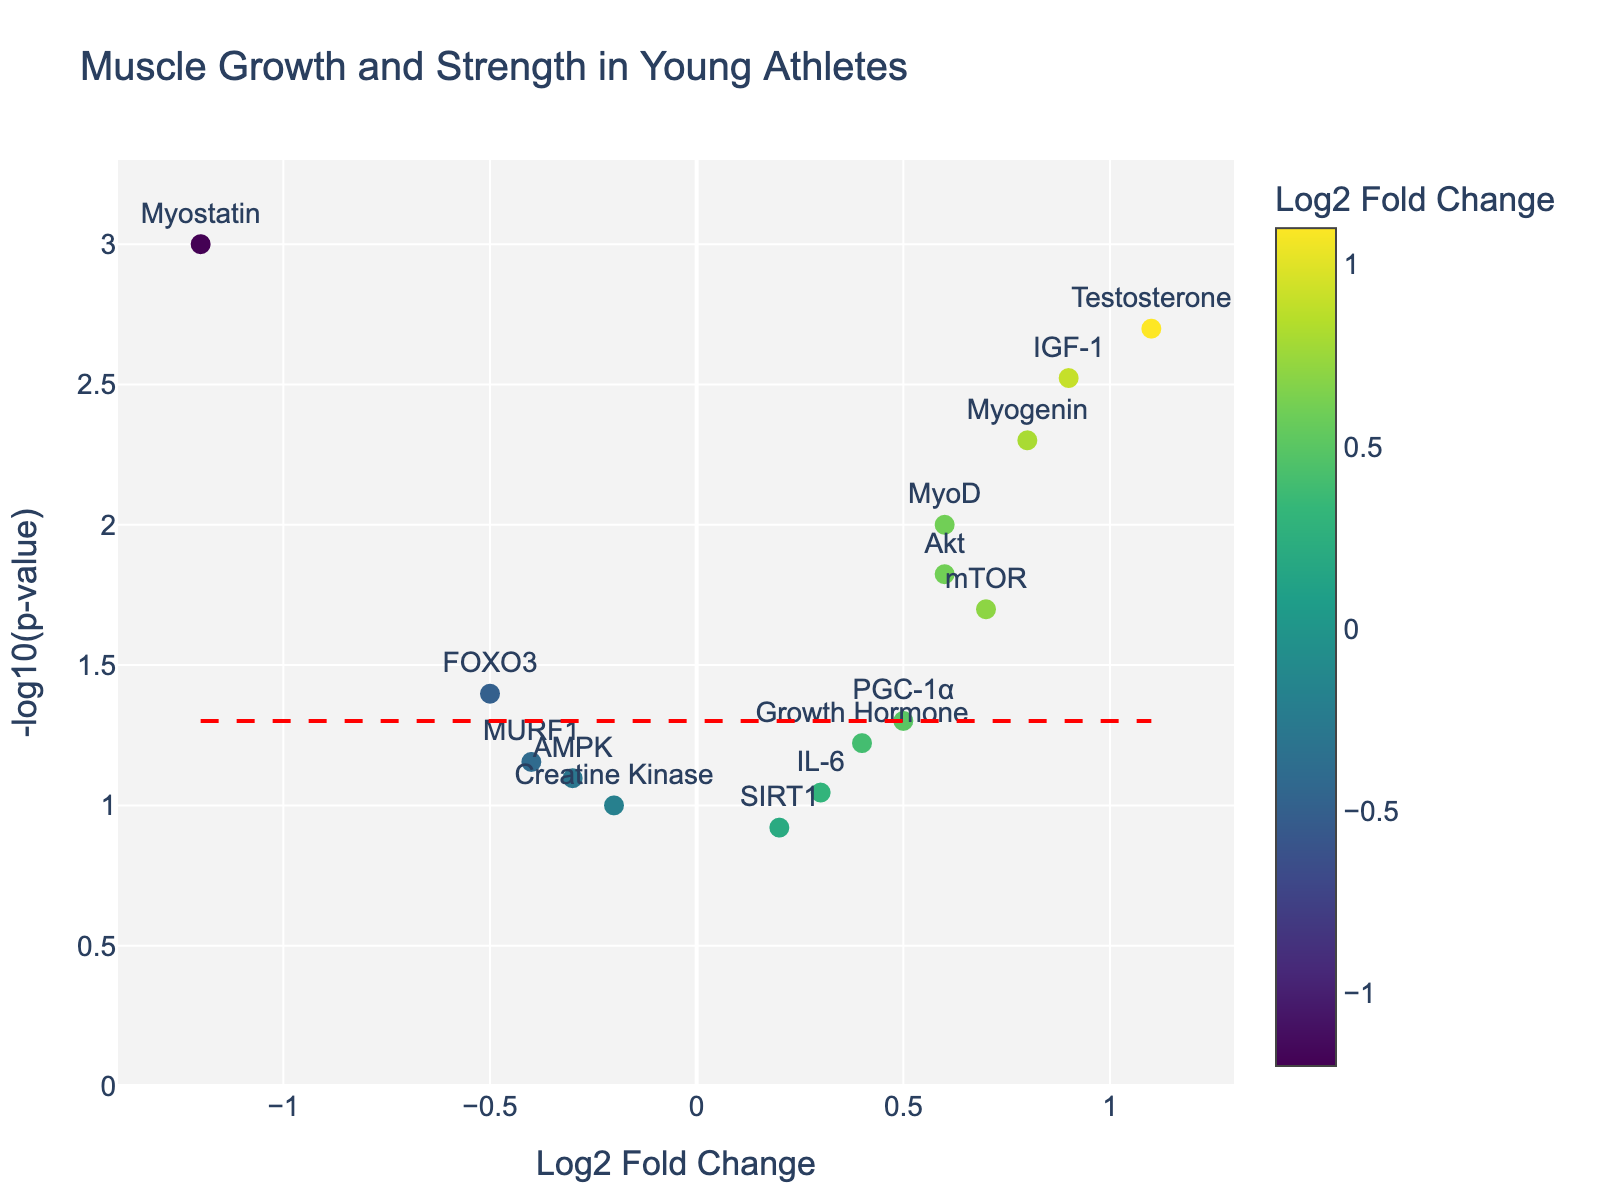What is the title of the figure? The title is displayed at the top of the volcano plot, indicating the graph’s focus.
Answer: Muscle Growth and Strength in Young Athletes How many genes have a Log2 Fold Change greater than 1? Look at the x-axis for points to the right of 1. There are two points: IGF-1 and Testosterone.
Answer: 2 Which gene has the highest -log10(p-value)? Find the data point with the maximum y-axis value. The point representing Myostatin is the highest on the y-axis.
Answer: Myostatin Are there any genes with both a negative Log2 Fold Change and a highly significant p-value (less than 0.05)? Check for points with a Log2 Fold Change less than 0 and a -log10(p-value) above the horizontal red line (-log10(0.05)). Myostatin and FOXO3 meet these criteria.
Answer: Myostatin, FOXO3 What is the Log2 Fold Change value of the gene with the lowest -log10(p-value)? Identify the lowest y-axis value and match it with the corresponding x-axis value. SIRT1 has the lowest -log10(p-value).
Answer: 0.2 Compare Testosterone and Myostatin in terms of p-value and Log2 Fold Change. Which one is more significant and which one has a higher Log2 Fold Change? Testosterone has a Log2 Fold Change of 1.1 and a p-value of 0.002, while Myostatin has a Log2 Fold Change of -1.2 and a p-value of 0.001. Significance is based on p-value: Myostatin is slightly more significant and Testosterone has a higher Log2 Fold Change.
Answer: Myostatin is more significant, Testosterone has a higher Log2 Fold Change What is the average Log2 Fold Change value of the genes with a p-value less than 0.05? Calculate the average of Log2 Fold Change for Myostatin, IGF-1, MyoD, Myogenin, Testosterone, and FOXO3. ((-1.2) + 0.9 + 0.6 + 0.8 + 1.1 + (-0.5)) / 6 = 0.2833.
Answer: 0.28 Which gene shows the least effect on muscle growth and strength among those with p-values less than 0.05? Look for the gene closest to zero on the Log2 Fold Change axis with a p-value less than 0.05. PGC-1α has the Log2 Fold Change of 0.5.
Answer: PGC-1α 